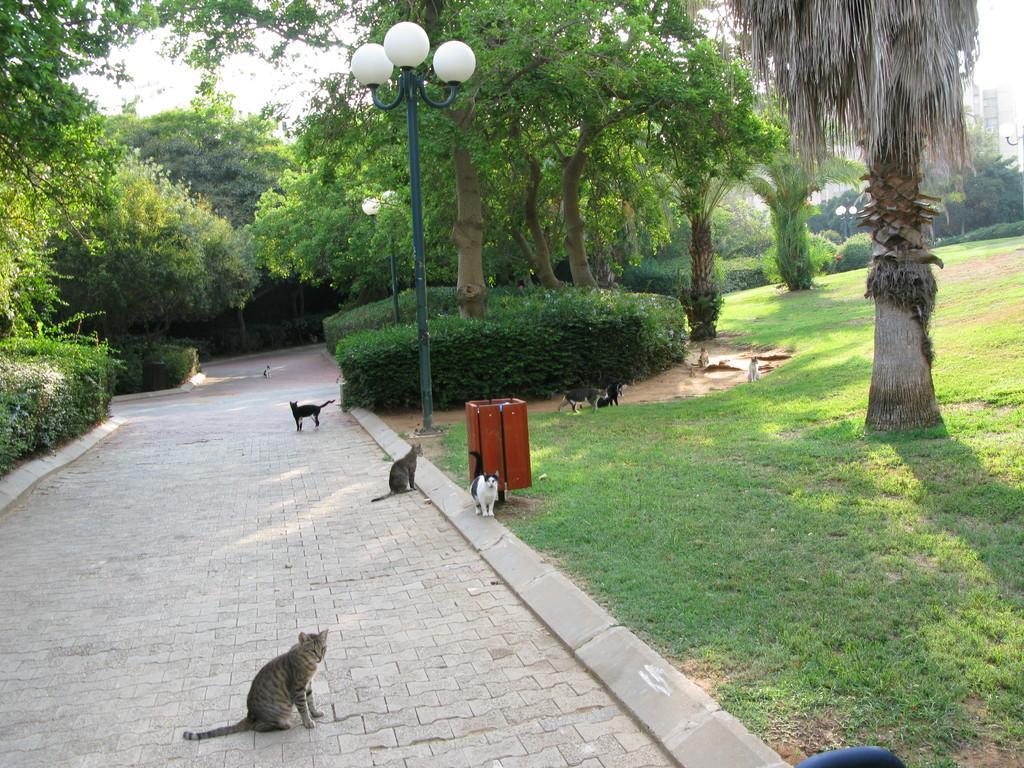Describe this image in one or two sentences. There are few cats on the way and there are plants and trees on either sides of it. 